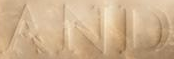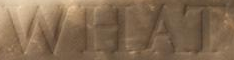What text is displayed in these images sequentially, separated by a semicolon? AND; WHAT 